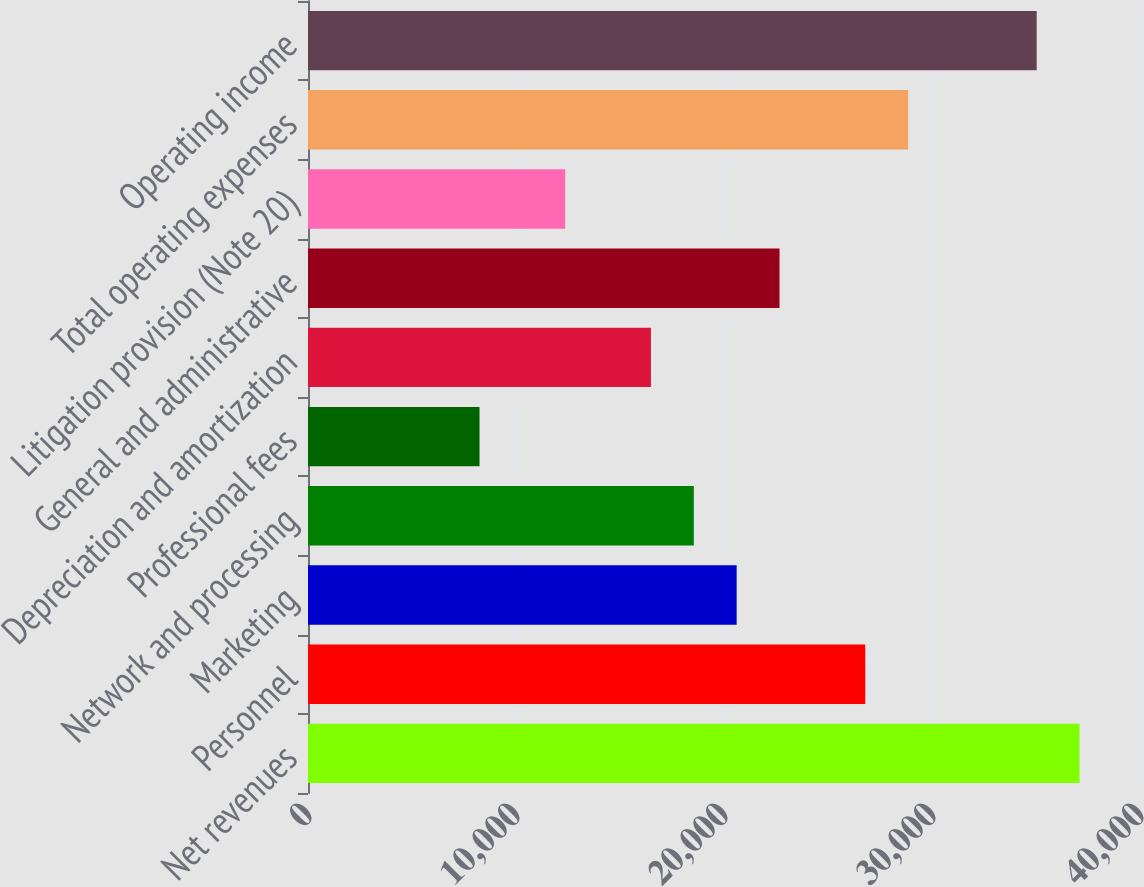Convert chart. <chart><loc_0><loc_0><loc_500><loc_500><bar_chart><fcel>Net revenues<fcel>Personnel<fcel>Marketing<fcel>Network and processing<fcel>Professional fees<fcel>Depreciation and amortization<fcel>General and administrative<fcel>Litigation provision (Note 20)<fcel>Total operating expenses<fcel>Operating income<nl><fcel>37092.7<fcel>26790.4<fcel>20609<fcel>18548.6<fcel>8246.27<fcel>16488.1<fcel>22669.5<fcel>12367.2<fcel>28850.9<fcel>35032.2<nl></chart> 